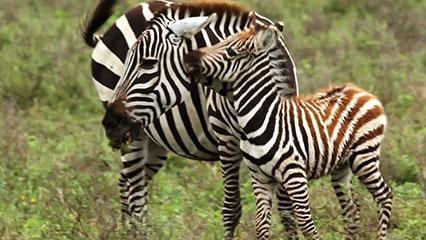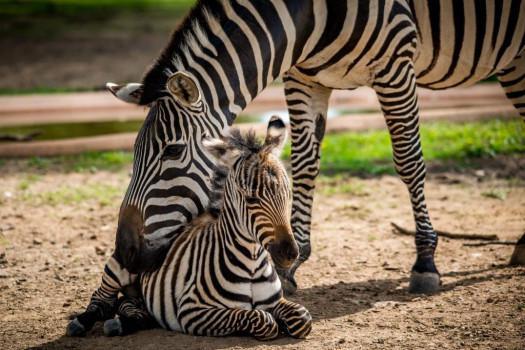The first image is the image on the left, the second image is the image on the right. Considering the images on both sides, is "The combined images include at least four zebras standing in profile with heads and necks curved to the ground." valid? Answer yes or no. No. The first image is the image on the left, the second image is the image on the right. Analyze the images presented: Is the assertion "The left and right image contains the same number of zebras." valid? Answer yes or no. Yes. 